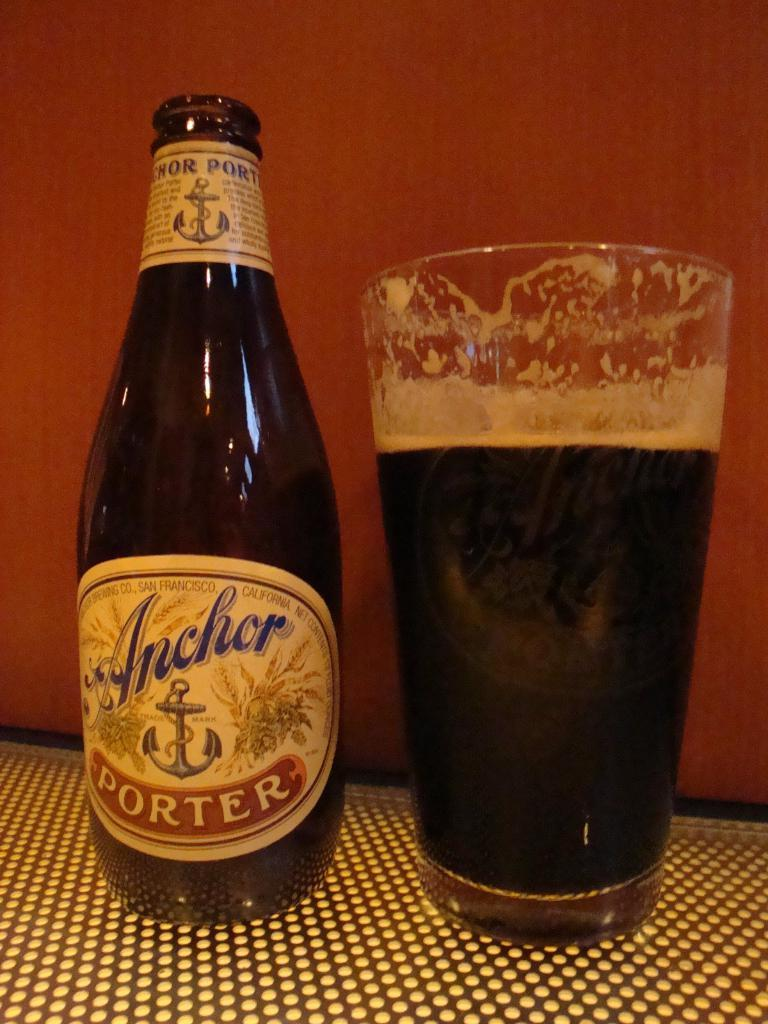<image>
Offer a succinct explanation of the picture presented. A bottle of Anchor Porter beer next to a glass of beer. 